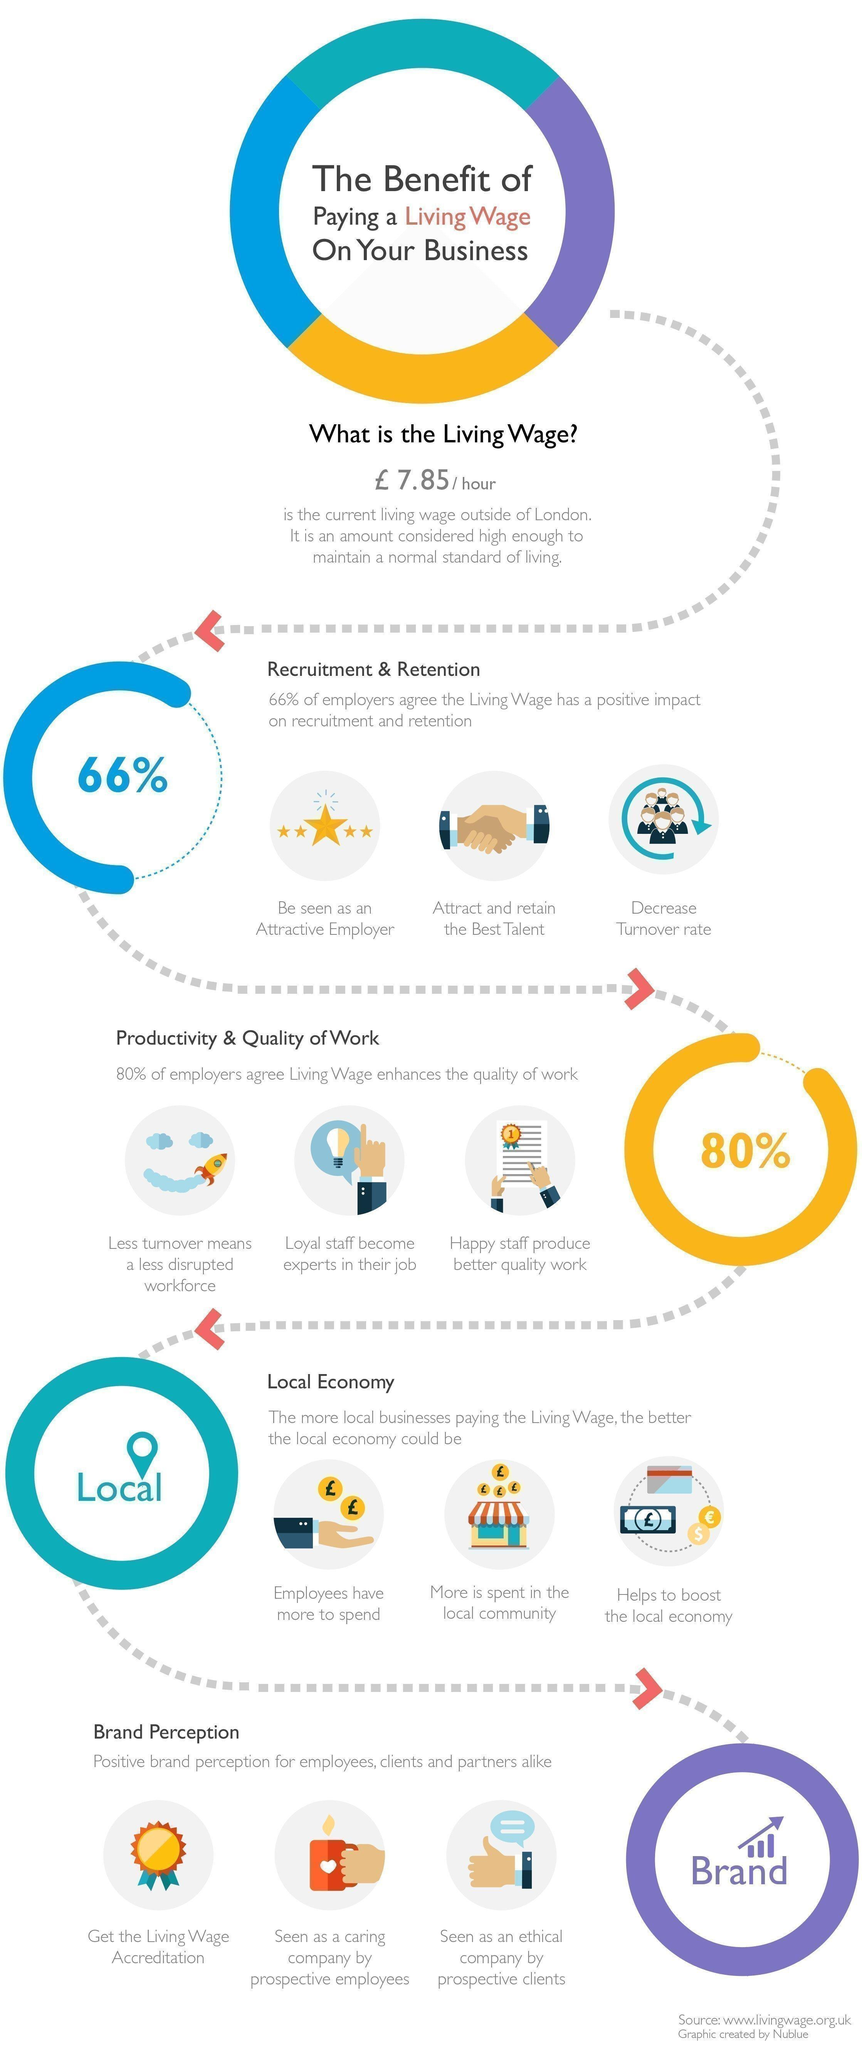What is the term used for - 'the amount considered high enough to maintain a normal standard of living' ?
Answer the question with a short phrase. Living wage What percentage of employers disagree that living wage has a positive impact ? 34% What is the living wage in London ? £ 7.85/hour How many stars are shown in the third image ? 5 What is the colour of the stars in the third image - red, blue or yellow ? Yellow What is the image shown for living wage accreditation - house, medal, cup or star ? Medal 